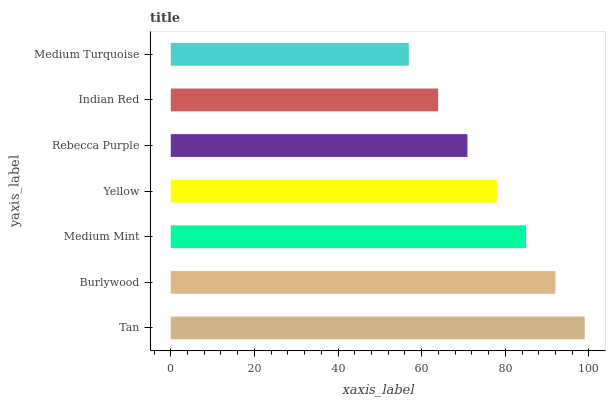Is Medium Turquoise the minimum?
Answer yes or no. Yes. Is Tan the maximum?
Answer yes or no. Yes. Is Burlywood the minimum?
Answer yes or no. No. Is Burlywood the maximum?
Answer yes or no. No. Is Tan greater than Burlywood?
Answer yes or no. Yes. Is Burlywood less than Tan?
Answer yes or no. Yes. Is Burlywood greater than Tan?
Answer yes or no. No. Is Tan less than Burlywood?
Answer yes or no. No. Is Yellow the high median?
Answer yes or no. Yes. Is Yellow the low median?
Answer yes or no. Yes. Is Tan the high median?
Answer yes or no. No. Is Rebecca Purple the low median?
Answer yes or no. No. 